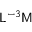Convert formula to latex. <formula><loc_0><loc_0><loc_500><loc_500>{ L } ^ { - 3 } { M }</formula> 